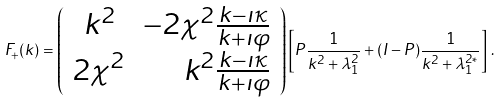<formula> <loc_0><loc_0><loc_500><loc_500>F _ { + } ( k ) = \left ( \begin{array} { c r } k ^ { 2 } & - 2 \chi ^ { 2 } \frac { k - \imath \kappa } { k + \imath \varphi } \\ 2 \chi ^ { 2 } & k ^ { 2 } \frac { k - \imath \kappa } { k + \imath \varphi } \end{array} \right ) \left [ P \frac { 1 } { k ^ { 2 } + \lambda ^ { 2 } _ { 1 } } + ( I - P ) \frac { 1 } { k ^ { 2 } + \lambda ^ { 2 * } _ { 1 } } \right ] \, .</formula> 